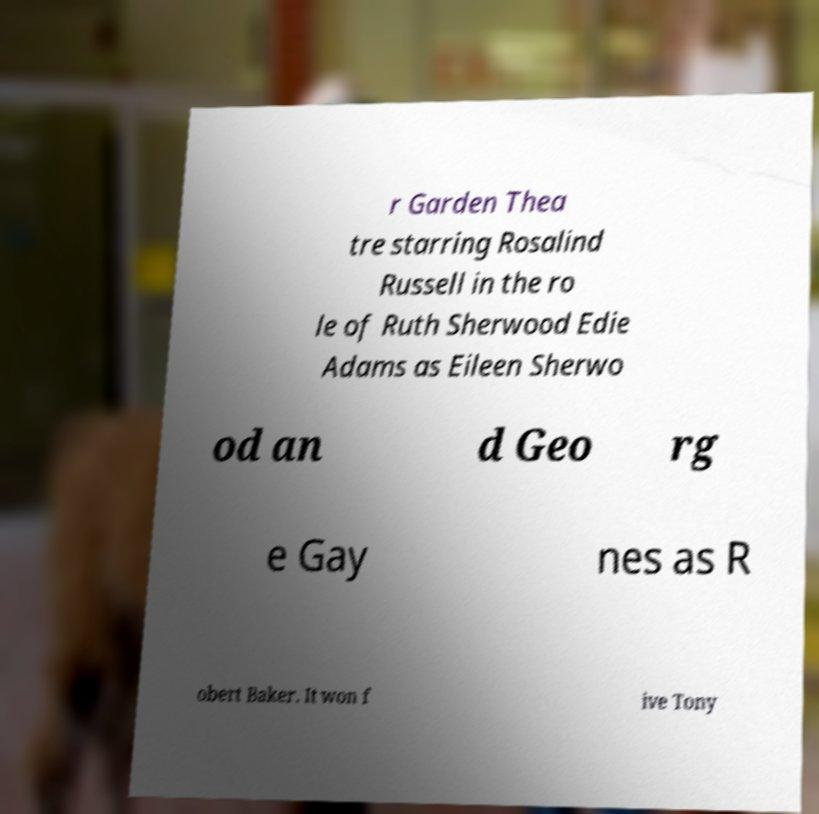Could you extract and type out the text from this image? r Garden Thea tre starring Rosalind Russell in the ro le of Ruth Sherwood Edie Adams as Eileen Sherwo od an d Geo rg e Gay nes as R obert Baker. It won f ive Tony 